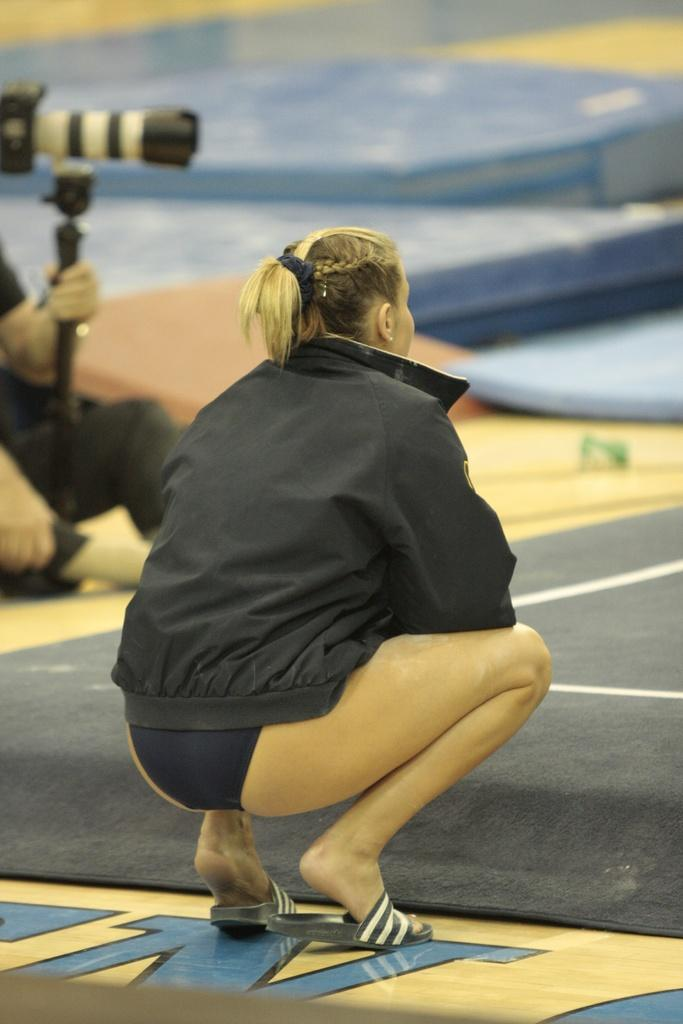What is the primary subject of the image? There is a woman in the image. Can you describe the other human in the image? The other human is holding a camera with the help of a stand. What might the person holding the camera be doing? The person holding the camera might be taking a picture or recording a video. What type of hook is visible on the woman's clothing in the image? There is no hook visible on the woman's clothing in the image. What kind of apparatus is being used to hold the curtain in the image? There is no curtain present in the image, so it is not possible to determine what kind of apparatus might be used to hold it. 